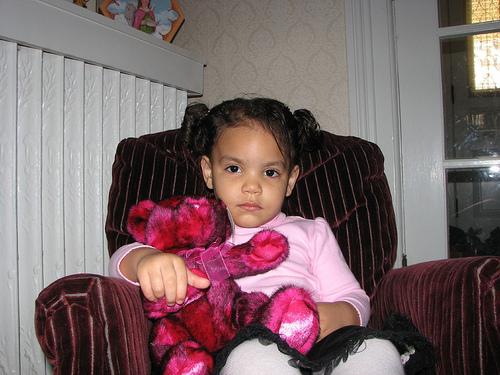What is the color of the baby's hair?
Answer briefly. Black. What is the picture behind and above the little girl?
Be succinct. Virgin mary. Is this girl upset?
Short answer required. Yes. What it the girl holding?
Give a very brief answer. Teddy bear. 